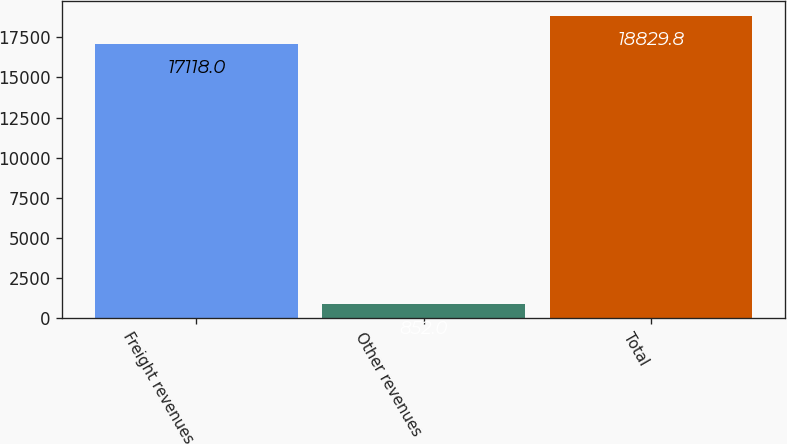<chart> <loc_0><loc_0><loc_500><loc_500><bar_chart><fcel>Freight revenues<fcel>Other revenues<fcel>Total<nl><fcel>17118<fcel>852<fcel>18829.8<nl></chart> 